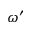<formula> <loc_0><loc_0><loc_500><loc_500>\omega ^ { \prime }</formula> 